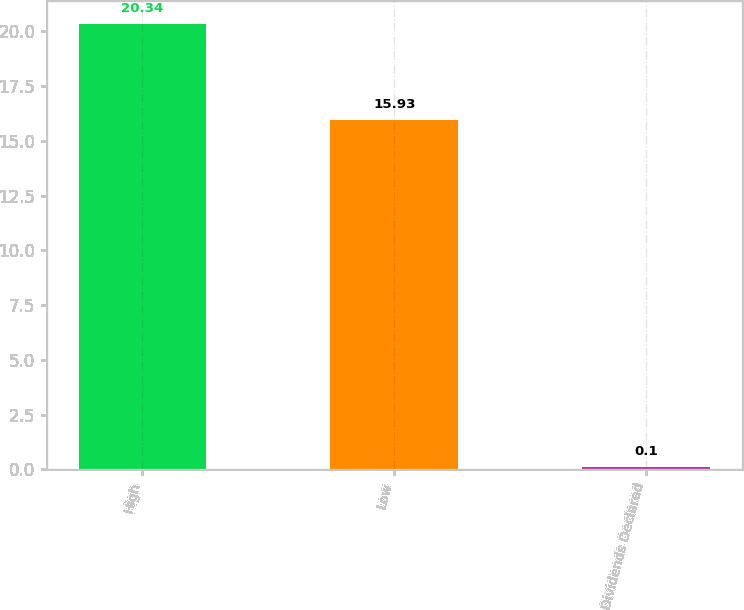Convert chart. <chart><loc_0><loc_0><loc_500><loc_500><bar_chart><fcel>High<fcel>Low<fcel>Dividends Declared<nl><fcel>20.34<fcel>15.93<fcel>0.1<nl></chart> 